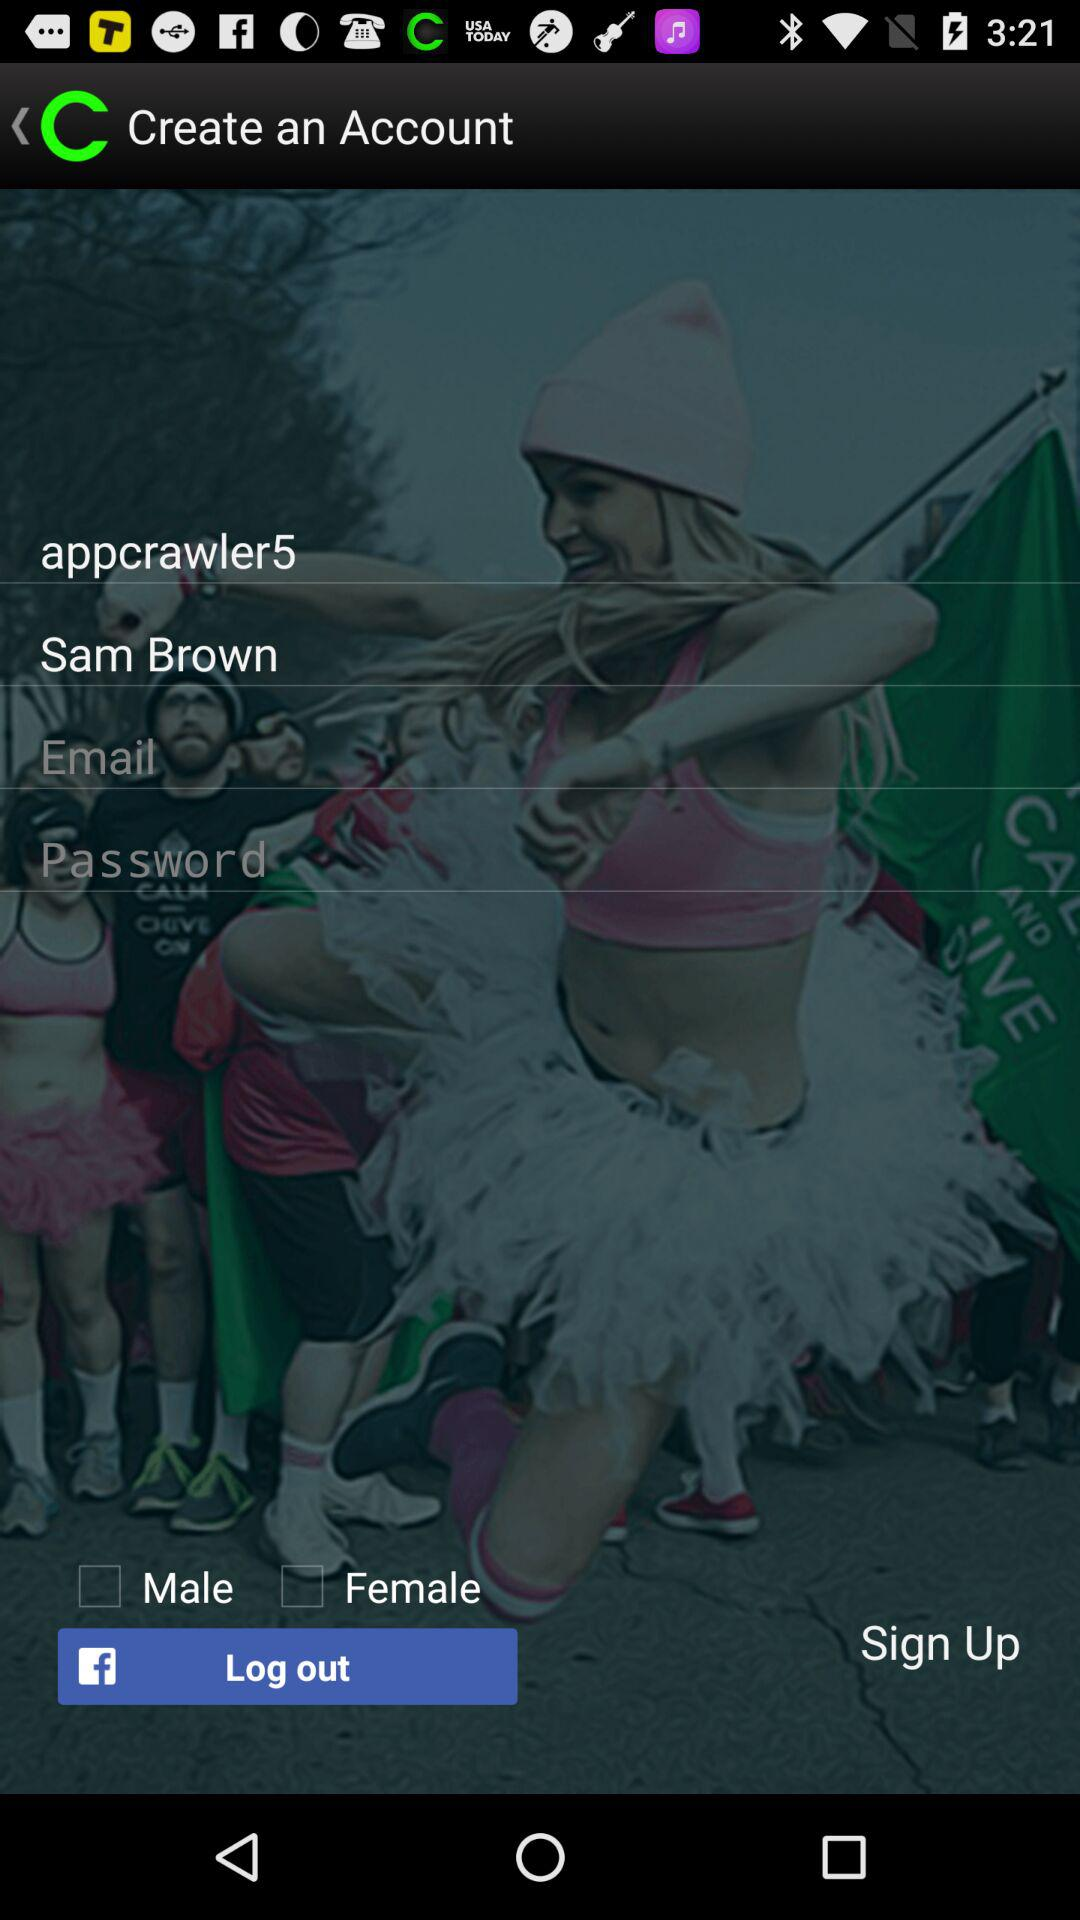How many input fields are there for entering personal information?
Answer the question using a single word or phrase. 4 